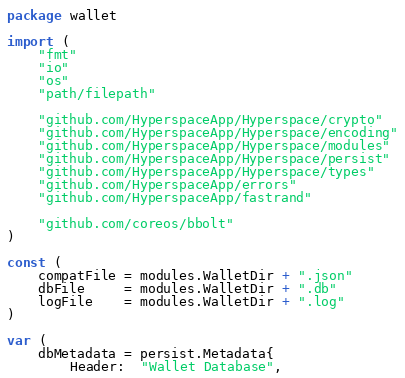<code> <loc_0><loc_0><loc_500><loc_500><_Go_>package wallet

import (
	"fmt"
	"io"
	"os"
	"path/filepath"

	"github.com/HyperspaceApp/Hyperspace/crypto"
	"github.com/HyperspaceApp/Hyperspace/encoding"
	"github.com/HyperspaceApp/Hyperspace/modules"
	"github.com/HyperspaceApp/Hyperspace/persist"
	"github.com/HyperspaceApp/Hyperspace/types"
	"github.com/HyperspaceApp/errors"
	"github.com/HyperspaceApp/fastrand"

	"github.com/coreos/bbolt"
)

const (
	compatFile = modules.WalletDir + ".json"
	dbFile     = modules.WalletDir + ".db"
	logFile    = modules.WalletDir + ".log"
)

var (
	dbMetadata = persist.Metadata{
		Header:  "Wallet Database",</code> 